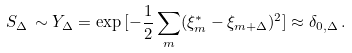<formula> <loc_0><loc_0><loc_500><loc_500>S _ { \Delta } \, \sim Y _ { \Delta } = \exp { [ - \frac { 1 } { 2 } \sum _ { m } ( \xi _ { m } ^ { * } - \xi _ { m + \Delta } ) ^ { 2 } ] } \approx \delta _ { 0 , \Delta } \, .</formula> 